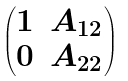Convert formula to latex. <formula><loc_0><loc_0><loc_500><loc_500>\begin{pmatrix} 1 & A _ { 1 2 } \\ 0 & A _ { 2 2 } \end{pmatrix}</formula> 